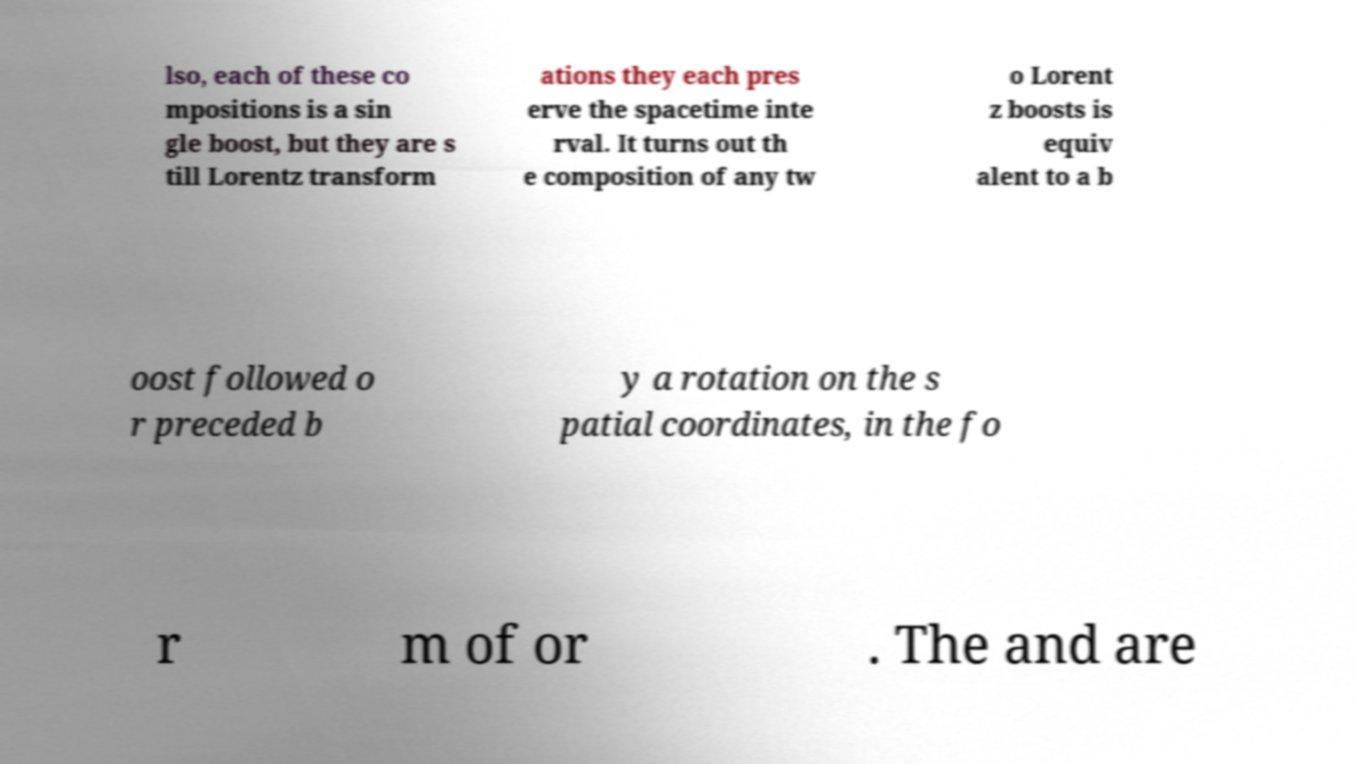Please read and relay the text visible in this image. What does it say? lso, each of these co mpositions is a sin gle boost, but they are s till Lorentz transform ations they each pres erve the spacetime inte rval. It turns out th e composition of any tw o Lorent z boosts is equiv alent to a b oost followed o r preceded b y a rotation on the s patial coordinates, in the fo r m of or . The and are 